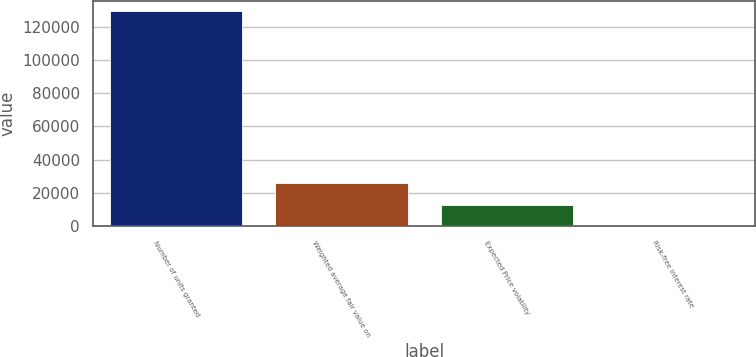Convert chart. <chart><loc_0><loc_0><loc_500><loc_500><bar_chart><fcel>Number of units granted<fcel>Weighted average fair value on<fcel>Expected Price volatility<fcel>Risk-free interest rate<nl><fcel>129150<fcel>25830.5<fcel>12915.6<fcel>0.63<nl></chart> 